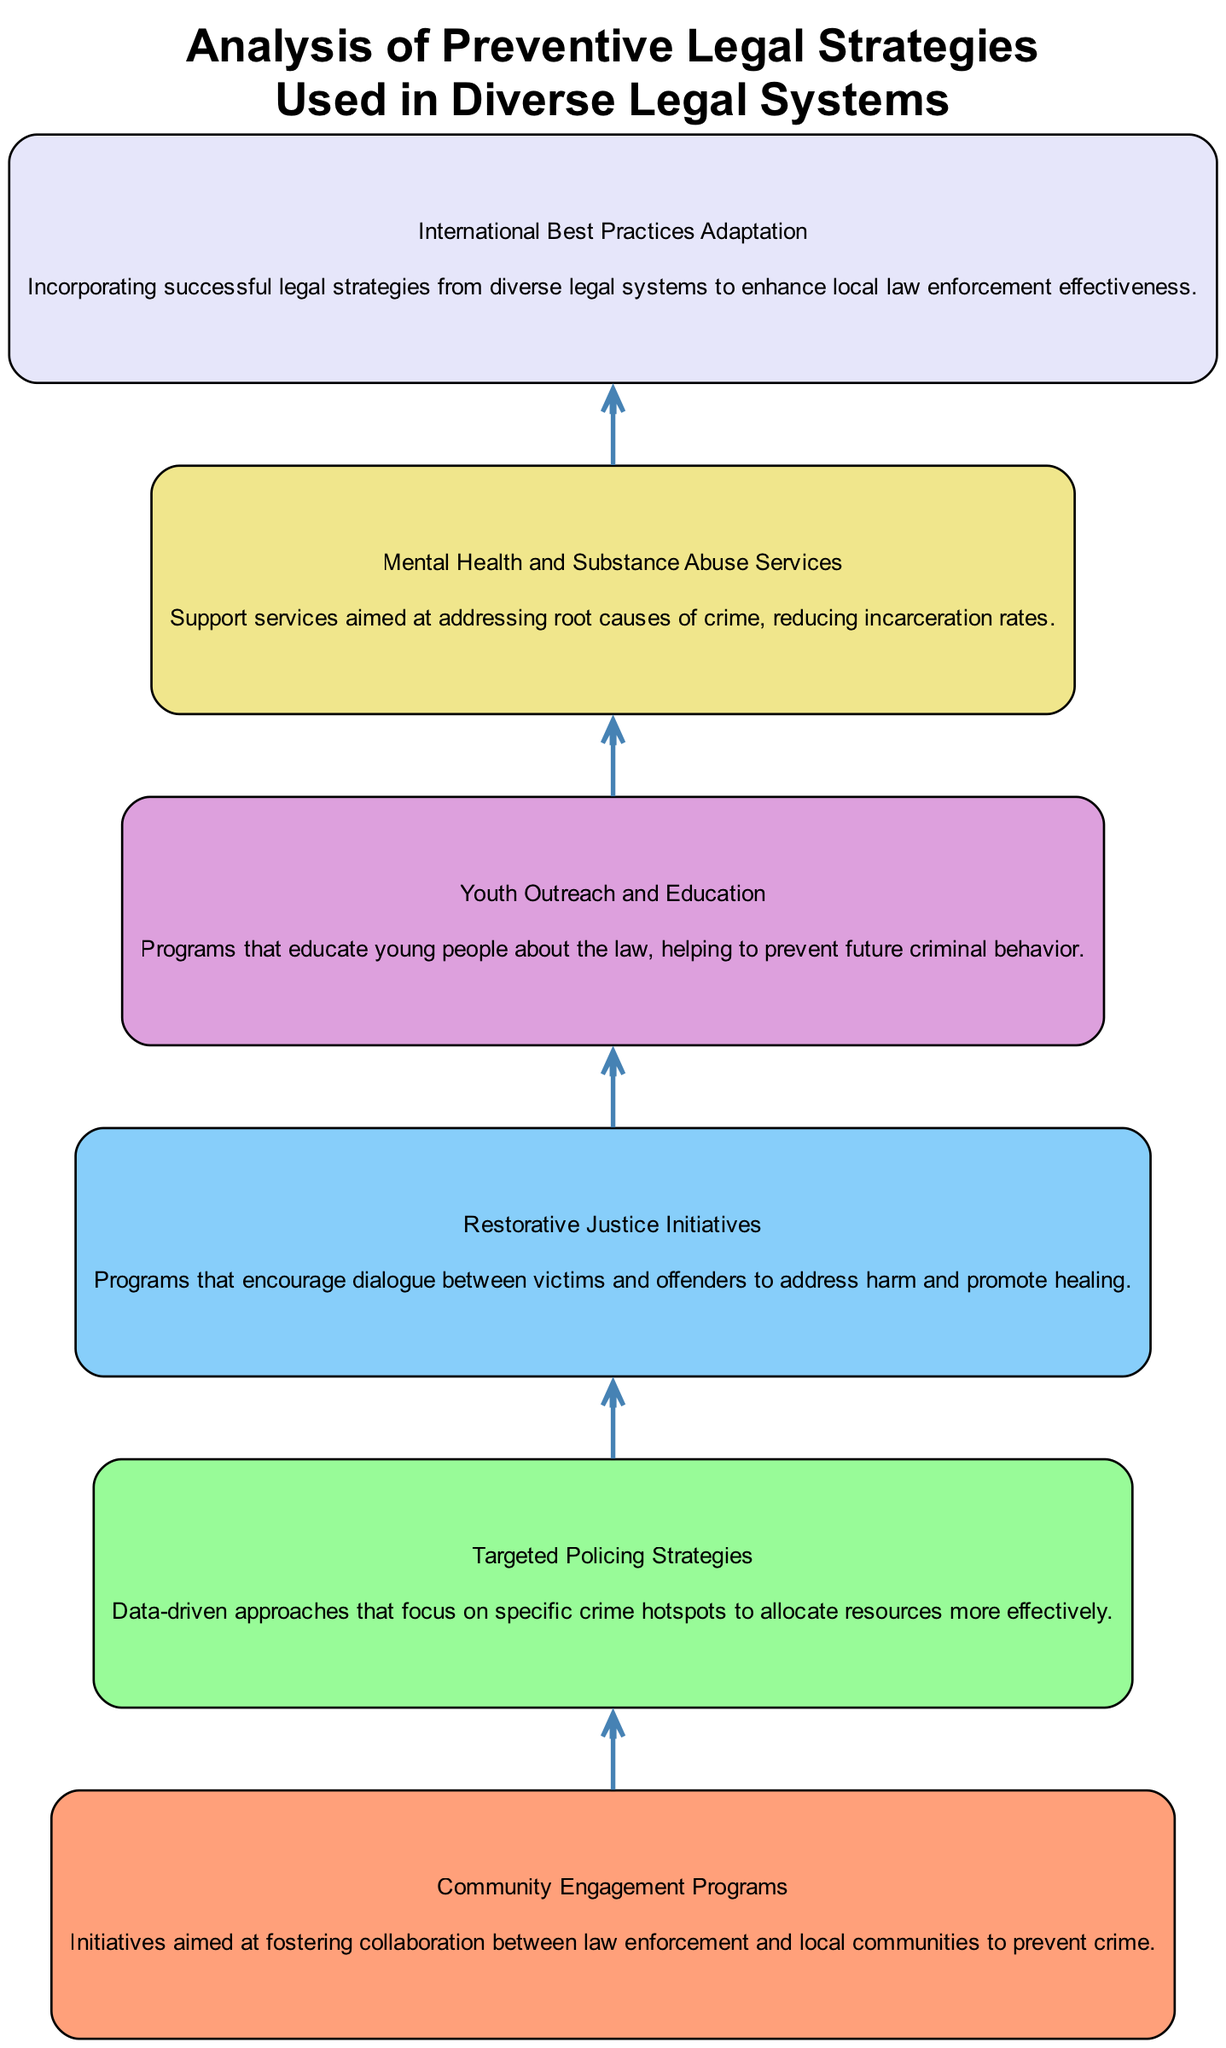What is the first node in the diagram? The diagram's flow starts from the bottom, and the first node listed is "Community Engagement Programs."
Answer: Community Engagement Programs How many nodes are there in total? To find the total number of nodes, count each distinct element listed in the diagram. There are six elements (nodes) in total.
Answer: 6 Which node follows "Restorative Justice Initiatives"? "Restorative Justice Initiatives" is followed by "Youth Outreach and Education" according to the flow chart's sequential connections.
Answer: Youth Outreach and Education What is the last node in the flow chart? The last node in the bottom-up flow chart is "International Best Practices Adaptation," which is positioned at the top of the diagram.
Answer: International Best Practices Adaptation Do "Targeted Policing Strategies" and "Mental Health and Substance Abuse Services" share a direct connection? There is no direct edge connecting "Targeted Policing Strategies" to "Mental Health and Substance Abuse Services," meaning they do not share a direct connection.
Answer: No Which nodes emphasize community involvement? The nodes that emphasize community involvement are "Community Engagement Programs" and "Youth Outreach and Education," as both focus on engaging community members and educating the youth.
Answer: Community Engagement Programs, Youth Outreach and Education Which node is located directly above "Youth Outreach and Education"? The node that is directly above "Youth Outreach and Education" is "Restorative Justice Initiatives" in the upward flow of the diagram.
Answer: Restorative Justice Initiatives Identify a strategic node focused on law enforcement efficiency. "Targeted Policing Strategies" is specifically aimed at enhancing law enforcement efficiency through data-driven approaches targeting crime hotspots.
Answer: Targeted Policing Strategies What type of strategy does "Mental Health and Substance Abuse Services" represent? "Mental Health and Substance Abuse Services" represent preventive strategies aimed at addressing the root causes of crime, thereby reducing future criminal behavior.
Answer: Preventive strategies 